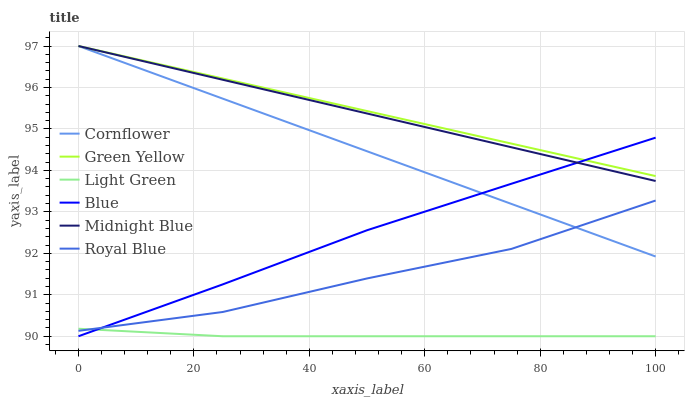Does Cornflower have the minimum area under the curve?
Answer yes or no. No. Does Cornflower have the maximum area under the curve?
Answer yes or no. No. Is Royal Blue the smoothest?
Answer yes or no. No. Is Midnight Blue the roughest?
Answer yes or no. No. Does Cornflower have the lowest value?
Answer yes or no. No. Does Royal Blue have the highest value?
Answer yes or no. No. Is Light Green less than Midnight Blue?
Answer yes or no. Yes. Is Cornflower greater than Light Green?
Answer yes or no. Yes. Does Light Green intersect Midnight Blue?
Answer yes or no. No. 